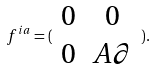<formula> <loc_0><loc_0><loc_500><loc_500>f ^ { i a } = ( \begin{array} { c c } 0 & 0 \\ 0 & A \partial \end{array} ) .</formula> 